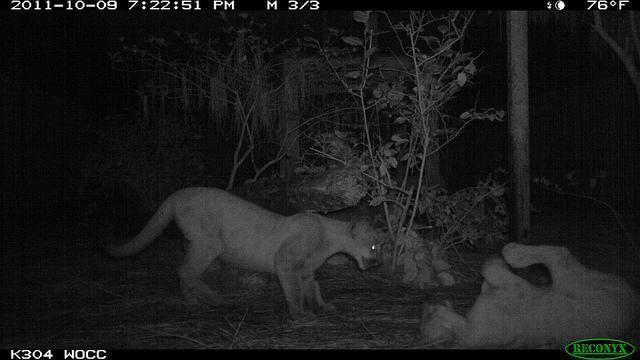How many pictures are there?
Give a very brief answer. 1. How many real animals can you see?
Give a very brief answer. 2. How many cats are there?
Give a very brief answer. 2. How many layers does the bus have?
Give a very brief answer. 0. 